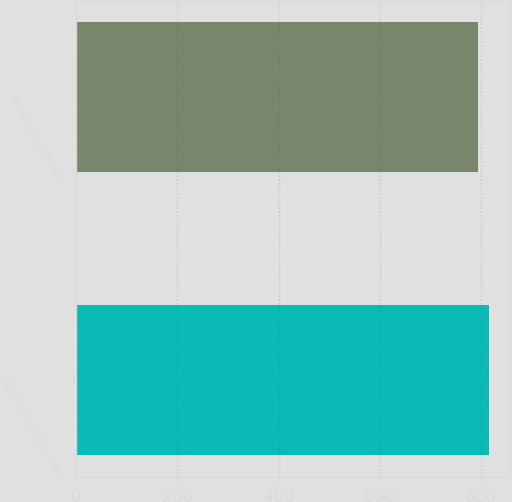Convert chart. <chart><loc_0><loc_0><loc_500><loc_500><bar_chart><fcel>Remaining cubic yards<fcel>Remaining tonnage<nl><fcel>816<fcel>794<nl></chart> 